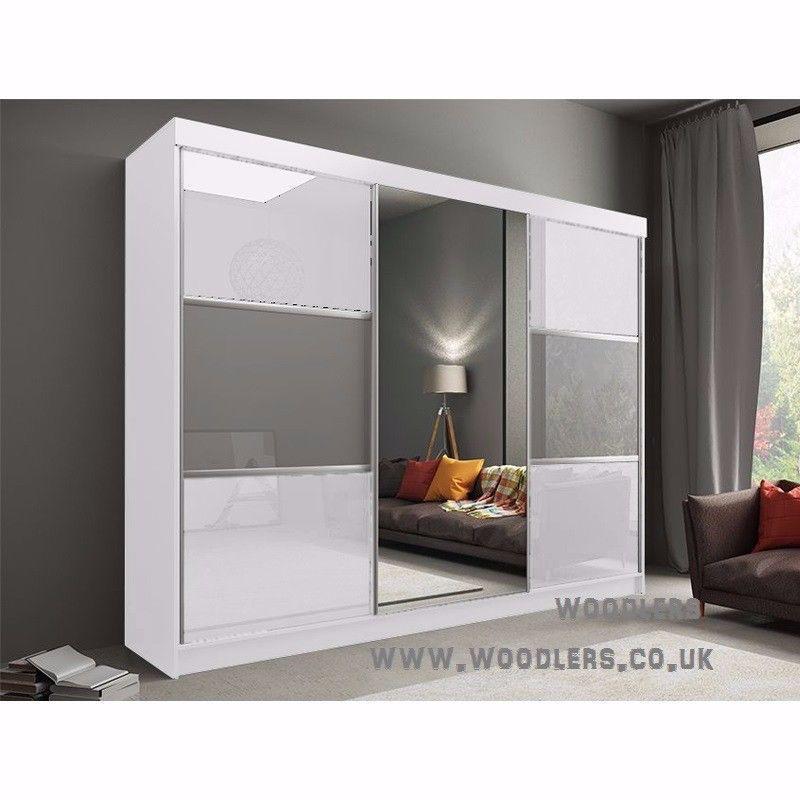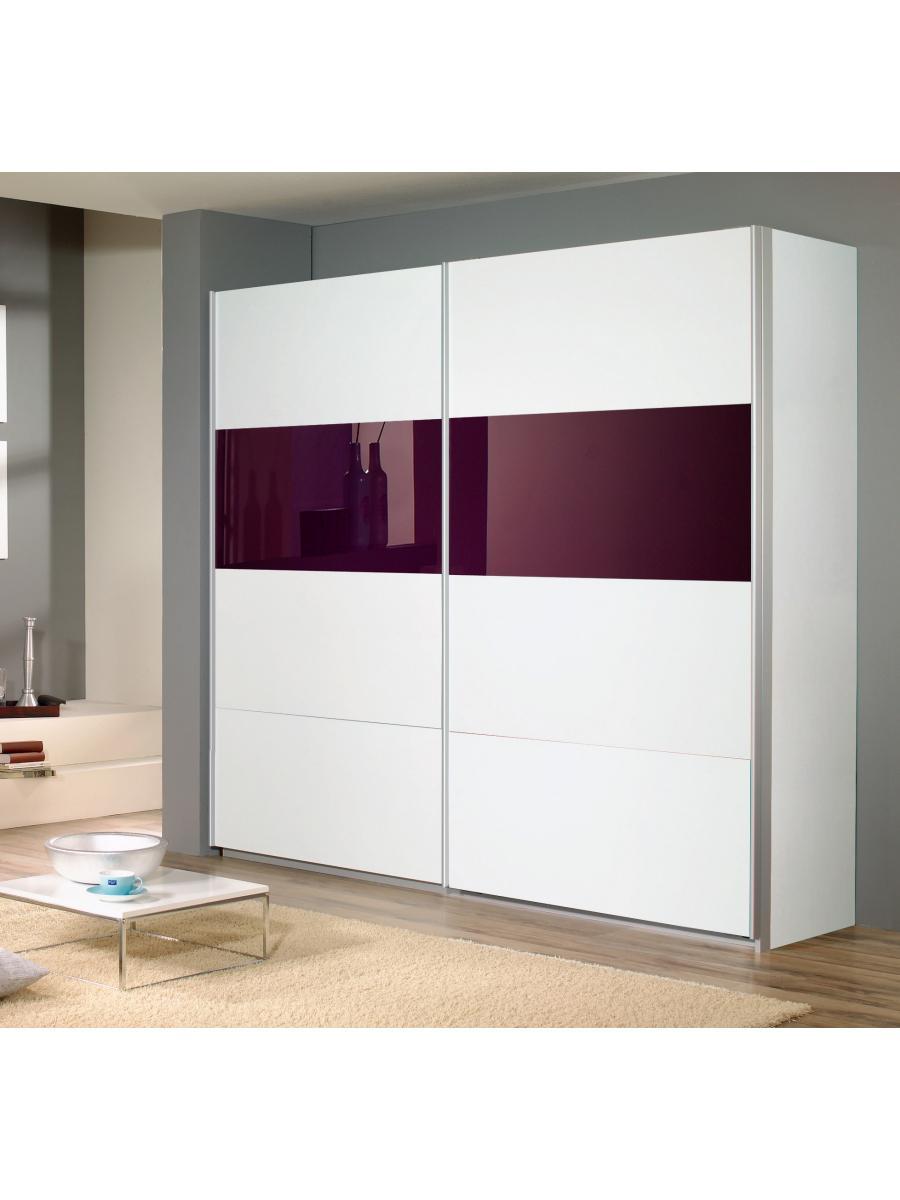The first image is the image on the left, the second image is the image on the right. Considering the images on both sides, is "there is a closet with a curtained window on the wall to the right" valid? Answer yes or no. Yes. 